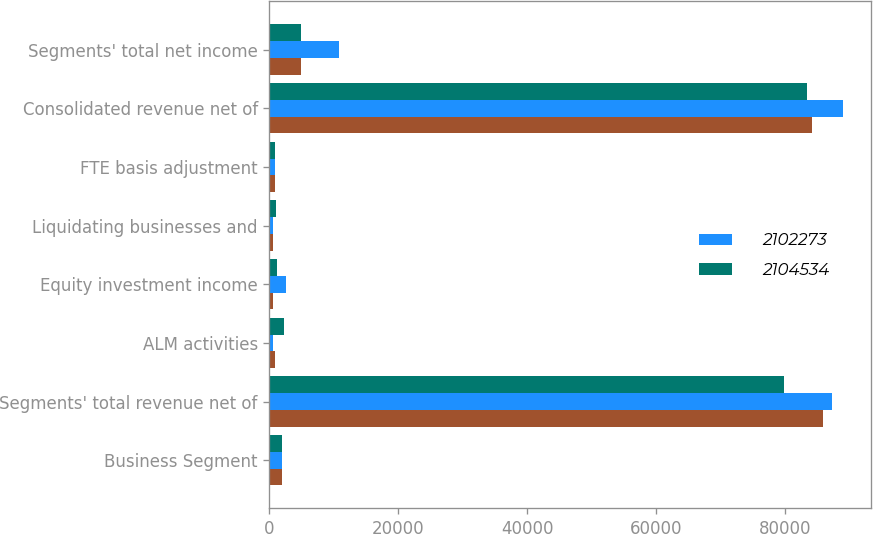<chart> <loc_0><loc_0><loc_500><loc_500><stacked_bar_chart><ecel><fcel>Business Segment<fcel>Segments' total revenue net of<fcel>ALM activities<fcel>Equity investment income<fcel>Liquidating businesses and<fcel>FTE basis adjustment<fcel>Consolidated revenue net of<fcel>Segments' total net income<nl><fcel>nan<fcel>2014<fcel>85831<fcel>804<fcel>601<fcel>512<fcel>869<fcel>84247<fcel>4829<nl><fcel>2.10227e+06<fcel>2013<fcel>87238<fcel>545<fcel>2610<fcel>498<fcel>859<fcel>88942<fcel>10719<nl><fcel>2.10453e+06<fcel>2012<fcel>79895<fcel>2266<fcel>1136<fcel>938<fcel>901<fcel>83334<fcel>4891<nl></chart> 